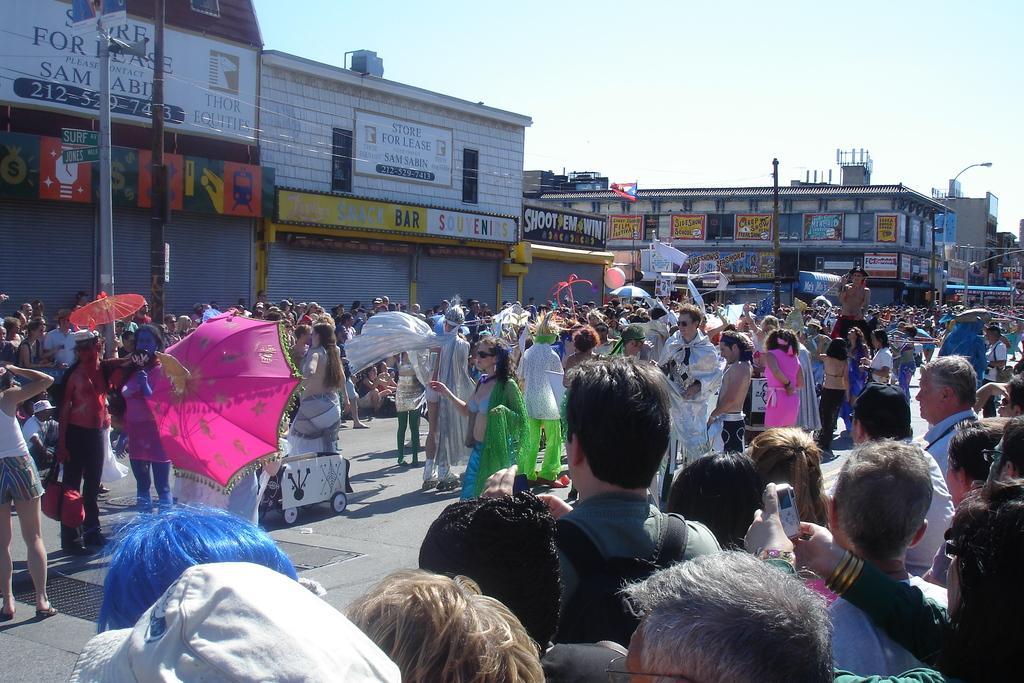How would you summarize this image in a sentence or two? In this image we can see a few people, among them, some people are holding the objects, there are some buildings, poles, shutters and boards with some text, in the background, we can see the sky. 